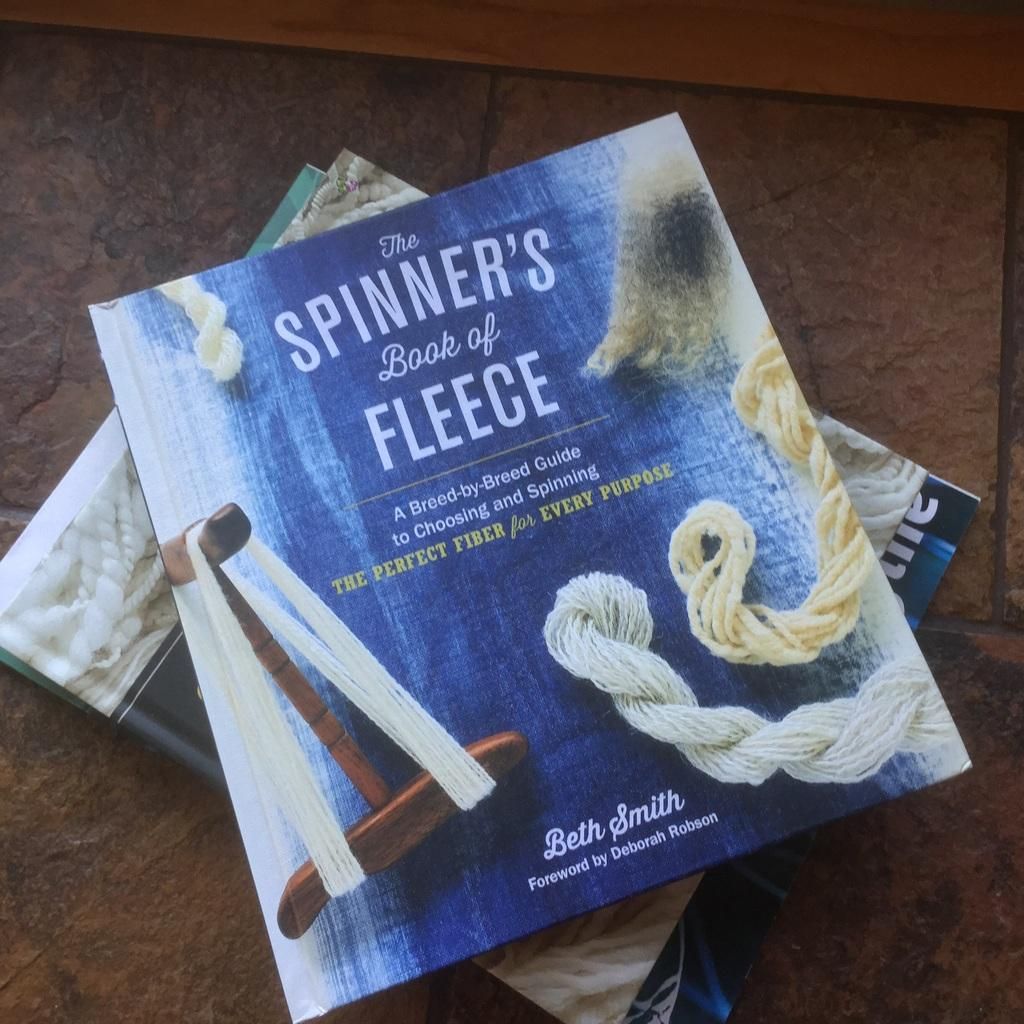What objects can be seen in the image? There are books in the image. Where are the books located? The books are on a surface. What type of cable can be seen connecting the trucks in the image? There are no trucks or cables present in the image; it only features books on a surface. 